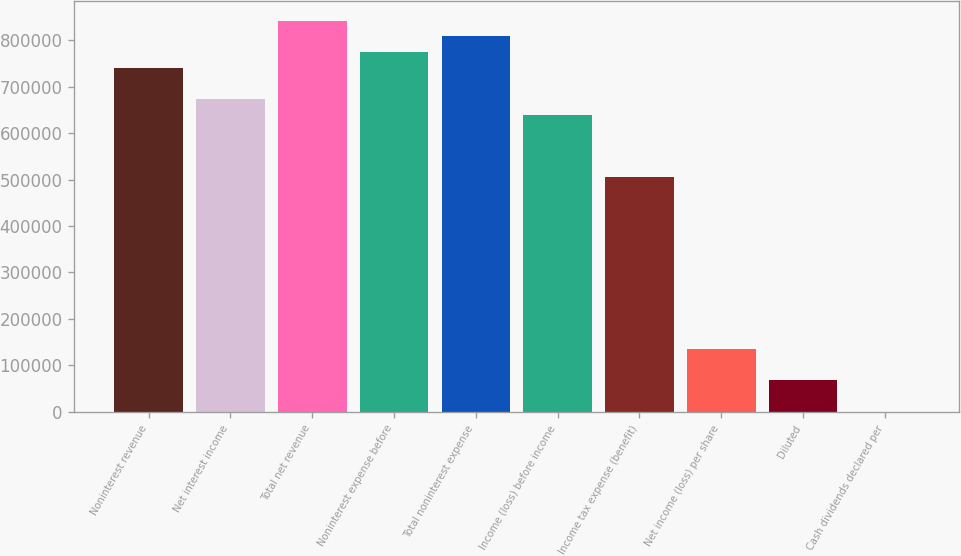<chart> <loc_0><loc_0><loc_500><loc_500><bar_chart><fcel>Noninterest revenue<fcel>Net interest income<fcel>Total net revenue<fcel>Noninterest expense before<fcel>Total noninterest expense<fcel>Income (loss) before income<fcel>Income tax expense (benefit)<fcel>Net income (loss) per share<fcel>Diluted<fcel>Cash dividends declared per<nl><fcel>741149<fcel>673772<fcel>842215<fcel>774837<fcel>808526<fcel>640083<fcel>505329<fcel>134755<fcel>67377.5<fcel>0.34<nl></chart> 